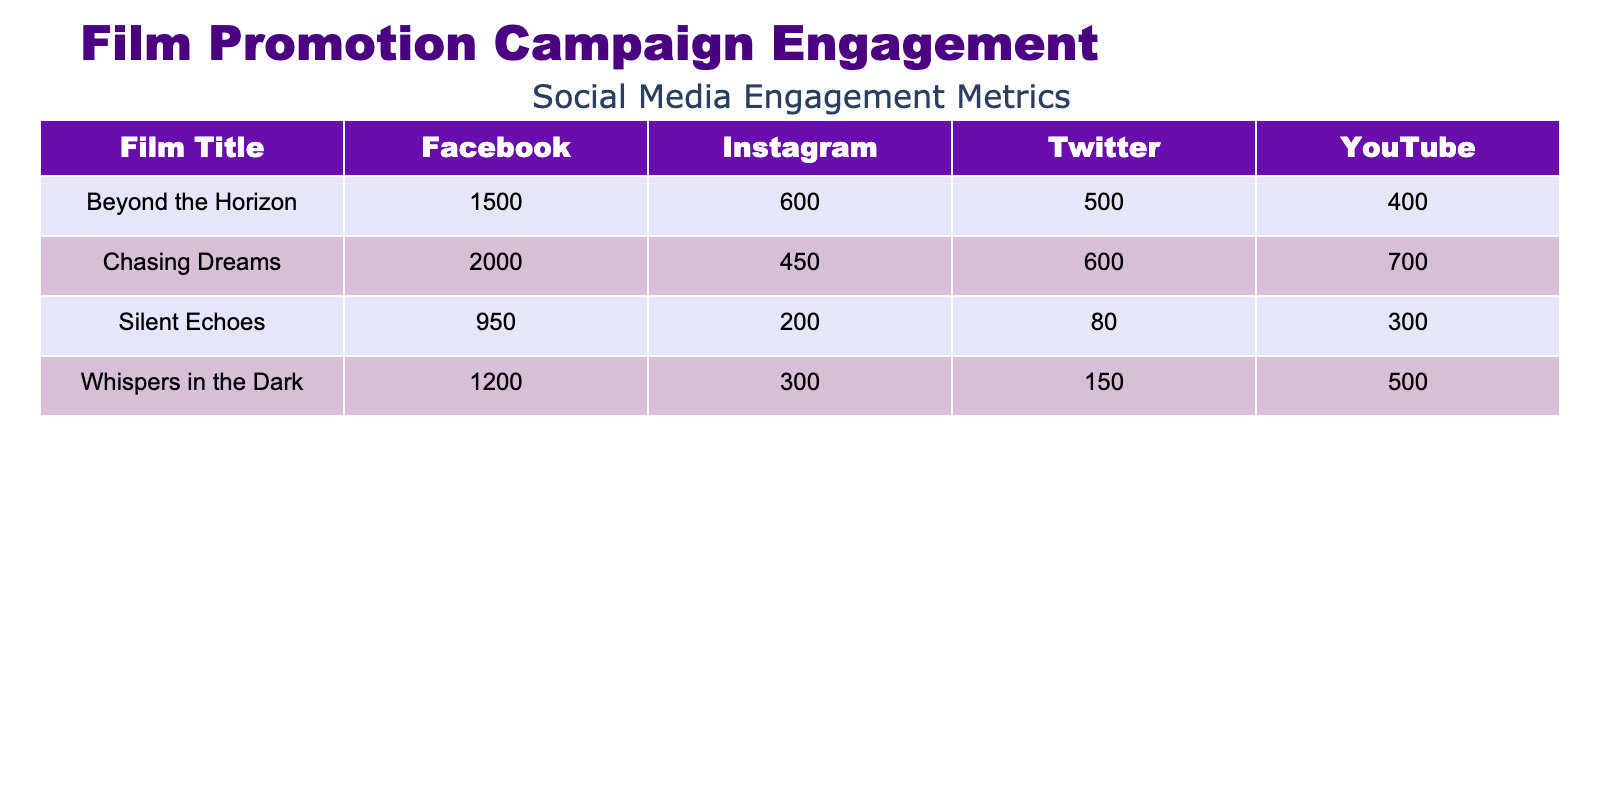What is the total number of 'Likes' for the film "Chasing Dreams"? The table shows that "Chasing Dreams" received 2000 likes on Facebook. Since Facebook is the only platform listed for likes for this film, the total number of likes is simply the engagement count listed.
Answer: 2000 Which film had the highest engagement count on Instagram? By examining the Instagram comments for each film, "Beyond the Horizon" had the highest count at 600, compared to "Whispers in the Dark" with 300 and "Chasing Dreams" with 450.
Answer: Beyond the Horizon Is the engagement count for "Silent Echoes" higher on YouTube or Twitter? For "Silent Echoes," the YouTube shares are 300, while the Twitter retweets are 80. Since 300 is greater than 80, the engagement count on YouTube is higher.
Answer: YouTube What is the average engagement count for all platforms of the film "Whispers in the Dark"? The engagement counts for "Whispers in the Dark" are 1200 (Facebook Likes), 300 (Instagram Comments), 150 (Twitter Retweets), and 500 (YouTube Shares). The total count adds up to 2150. To find the average, we divide by the number of platforms (4), resulting in an average of 537.5.
Answer: 537.5 Did "Beyond the Horizon" have a higher engagement count on Facebook compared to "Silent Echoes"? "Beyond the Horizon" has 1500 likes while "Silent Echoes" has 950 likes on Facebook. Since 1500 is greater than 950, the engagement count for "Beyond the Horizon" is indeed higher.
Answer: Yes What was the total number of 'Shares' across all films on YouTube? The YouTube shares for each film are 500 (Whispers in the Dark), 700 (Chasing Dreams), 300 (Silent Echoes), and 400 (Beyond the Horizon). Adding these together gives us 500 + 700 + 300 + 400 = 1900.
Answer: 1900 Which film had the lowest total engagement across all platforms? We calculate the total engagement for each film: "Whispers in the Dark" has 1200 (Likes) + 300 (Comments) + 150 (Retweets) + 500 (Shares) = 2150. "Chasing Dreams" has 2000 + 450 + 600 + 700 = 3850. "Silent Echoes" has 950 + 200 + 80 + 300 = 1530. "Beyond the Horizon" has 1500 + 600 + 500 + 400 = 3000. The lowest total engagement is for "Silent Echoes" with 1530.
Answer: Silent Echoes Is it true that "Chasing Dreams" had more comments than "Beyond the Horizon"? "Chasing Dreams" had 450 comments on Instagram, while "Beyond the Horizon" had 600. Since 450 is less than 600, the statement is false.
Answer: No What was the total engagement count for "Beyond the Horizon"? The counts are 1500 (Facebook Likes) + 600 (Instagram Comments) + 500 (Twitter Retweets) + 400 (YouTube Shares). Adding these gives 1500 + 600 + 500 + 400 = 3000 for total engagement.
Answer: 3000 